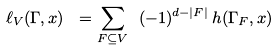<formula> <loc_0><loc_0><loc_500><loc_500>\ell _ { V } ( \Gamma , x ) \ = \sum _ { F \subseteq V } \ ( - 1 ) ^ { d - | F | } \, h ( \Gamma _ { F } , x )</formula> 